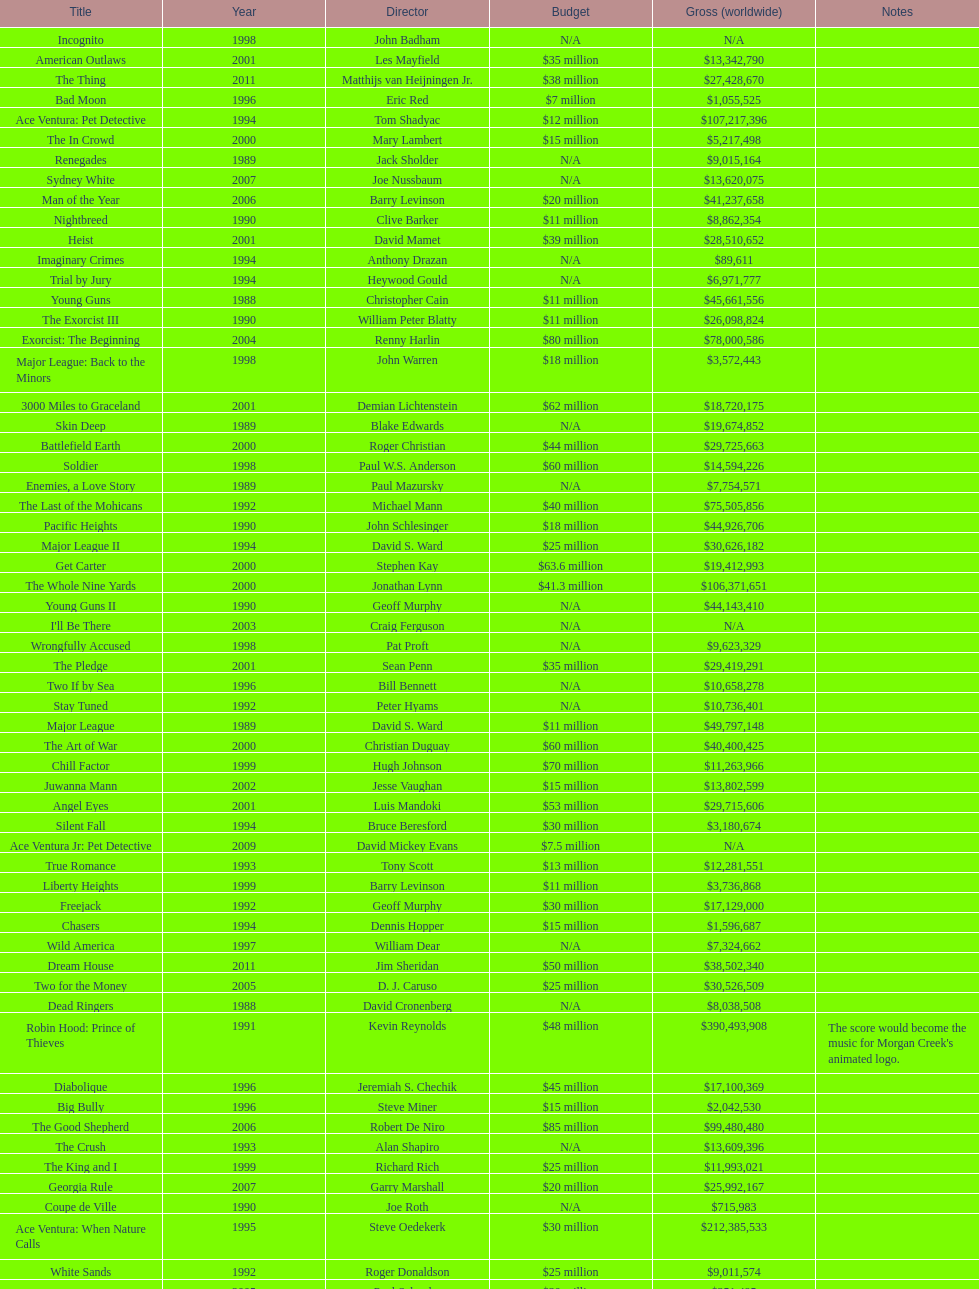Was the budget for young guns more or less than freejack's budget? Less. 